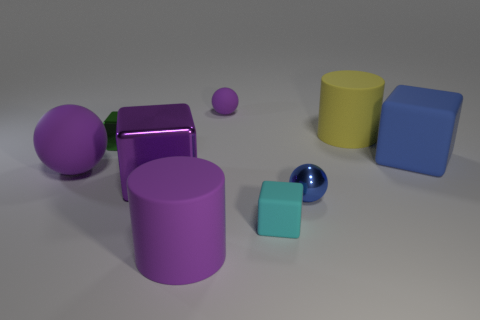Aside from color and size, are there any other differences between these objects? Yes, aside from color and size, the objects differ in shape and material properties. Shapes include spheres, cubes, and cylinders. The material properties vary as some objects have a shiny, reflective surface while others have a more subdued, matte appearance. 